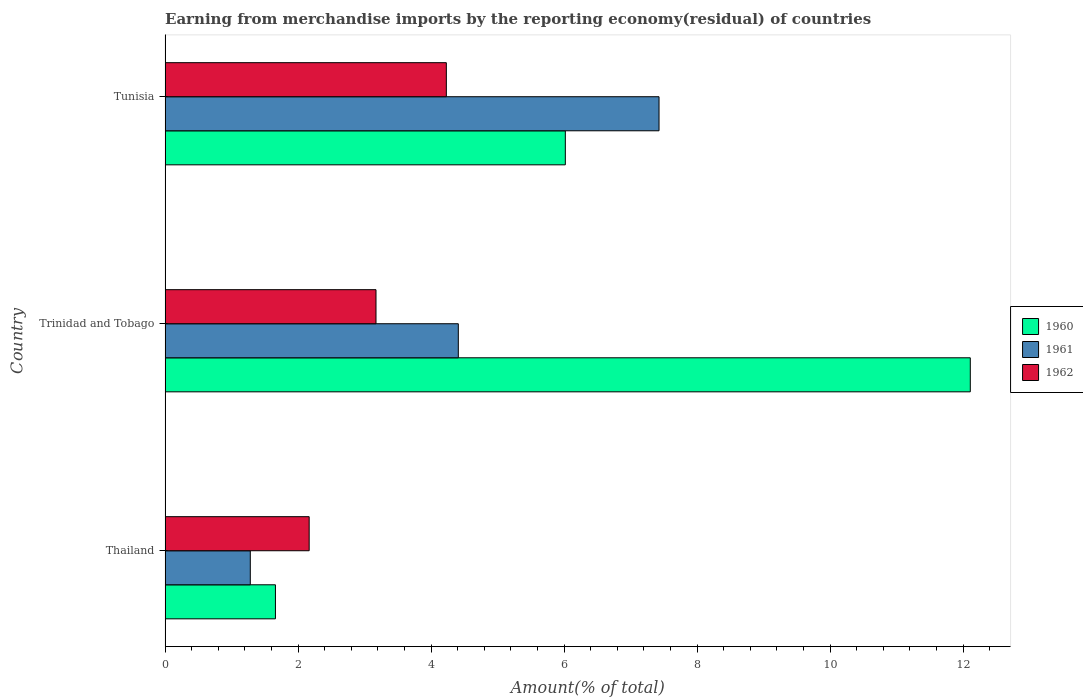How many different coloured bars are there?
Provide a short and direct response. 3. How many groups of bars are there?
Your answer should be compact. 3. Are the number of bars per tick equal to the number of legend labels?
Give a very brief answer. Yes. Are the number of bars on each tick of the Y-axis equal?
Your response must be concise. Yes. What is the label of the 3rd group of bars from the top?
Ensure brevity in your answer.  Thailand. What is the percentage of amount earned from merchandise imports in 1961 in Tunisia?
Your answer should be very brief. 7.43. Across all countries, what is the maximum percentage of amount earned from merchandise imports in 1961?
Your answer should be very brief. 7.43. Across all countries, what is the minimum percentage of amount earned from merchandise imports in 1960?
Make the answer very short. 1.66. In which country was the percentage of amount earned from merchandise imports in 1962 maximum?
Keep it short and to the point. Tunisia. In which country was the percentage of amount earned from merchandise imports in 1961 minimum?
Your answer should be compact. Thailand. What is the total percentage of amount earned from merchandise imports in 1961 in the graph?
Ensure brevity in your answer.  13.12. What is the difference between the percentage of amount earned from merchandise imports in 1962 in Thailand and that in Tunisia?
Your response must be concise. -2.06. What is the difference between the percentage of amount earned from merchandise imports in 1960 in Thailand and the percentage of amount earned from merchandise imports in 1962 in Trinidad and Tobago?
Your answer should be compact. -1.51. What is the average percentage of amount earned from merchandise imports in 1961 per country?
Your response must be concise. 4.37. What is the difference between the percentage of amount earned from merchandise imports in 1962 and percentage of amount earned from merchandise imports in 1960 in Tunisia?
Provide a short and direct response. -1.79. In how many countries, is the percentage of amount earned from merchandise imports in 1960 greater than 11.2 %?
Your answer should be compact. 1. What is the ratio of the percentage of amount earned from merchandise imports in 1961 in Trinidad and Tobago to that in Tunisia?
Offer a terse response. 0.59. What is the difference between the highest and the second highest percentage of amount earned from merchandise imports in 1962?
Offer a very short reply. 1.06. What is the difference between the highest and the lowest percentage of amount earned from merchandise imports in 1962?
Your answer should be compact. 2.06. Is the sum of the percentage of amount earned from merchandise imports in 1962 in Trinidad and Tobago and Tunisia greater than the maximum percentage of amount earned from merchandise imports in 1960 across all countries?
Offer a terse response. No. What does the 1st bar from the top in Thailand represents?
Make the answer very short. 1962. What does the 1st bar from the bottom in Thailand represents?
Ensure brevity in your answer.  1960. Are all the bars in the graph horizontal?
Provide a succinct answer. Yes. Does the graph contain any zero values?
Offer a very short reply. No. Does the graph contain grids?
Your answer should be compact. No. What is the title of the graph?
Your answer should be very brief. Earning from merchandise imports by the reporting economy(residual) of countries. What is the label or title of the X-axis?
Provide a succinct answer. Amount(% of total). What is the Amount(% of total) in 1960 in Thailand?
Keep it short and to the point. 1.66. What is the Amount(% of total) in 1961 in Thailand?
Provide a succinct answer. 1.28. What is the Amount(% of total) in 1962 in Thailand?
Offer a very short reply. 2.17. What is the Amount(% of total) of 1960 in Trinidad and Tobago?
Make the answer very short. 12.11. What is the Amount(% of total) in 1961 in Trinidad and Tobago?
Make the answer very short. 4.41. What is the Amount(% of total) in 1962 in Trinidad and Tobago?
Offer a very short reply. 3.17. What is the Amount(% of total) in 1960 in Tunisia?
Offer a terse response. 6.02. What is the Amount(% of total) of 1961 in Tunisia?
Provide a short and direct response. 7.43. What is the Amount(% of total) of 1962 in Tunisia?
Your answer should be very brief. 4.23. Across all countries, what is the maximum Amount(% of total) in 1960?
Offer a very short reply. 12.11. Across all countries, what is the maximum Amount(% of total) in 1961?
Your response must be concise. 7.43. Across all countries, what is the maximum Amount(% of total) in 1962?
Provide a short and direct response. 4.23. Across all countries, what is the minimum Amount(% of total) in 1960?
Provide a succinct answer. 1.66. Across all countries, what is the minimum Amount(% of total) of 1961?
Your answer should be compact. 1.28. Across all countries, what is the minimum Amount(% of total) in 1962?
Give a very brief answer. 2.17. What is the total Amount(% of total) in 1960 in the graph?
Make the answer very short. 19.78. What is the total Amount(% of total) in 1961 in the graph?
Offer a terse response. 13.12. What is the total Amount(% of total) of 1962 in the graph?
Your answer should be very brief. 9.57. What is the difference between the Amount(% of total) in 1960 in Thailand and that in Trinidad and Tobago?
Offer a terse response. -10.45. What is the difference between the Amount(% of total) of 1961 in Thailand and that in Trinidad and Tobago?
Offer a very short reply. -3.13. What is the difference between the Amount(% of total) of 1962 in Thailand and that in Trinidad and Tobago?
Keep it short and to the point. -1. What is the difference between the Amount(% of total) in 1960 in Thailand and that in Tunisia?
Your response must be concise. -4.36. What is the difference between the Amount(% of total) of 1961 in Thailand and that in Tunisia?
Offer a terse response. -6.15. What is the difference between the Amount(% of total) in 1962 in Thailand and that in Tunisia?
Give a very brief answer. -2.06. What is the difference between the Amount(% of total) in 1960 in Trinidad and Tobago and that in Tunisia?
Your answer should be very brief. 6.09. What is the difference between the Amount(% of total) of 1961 in Trinidad and Tobago and that in Tunisia?
Offer a terse response. -3.02. What is the difference between the Amount(% of total) of 1962 in Trinidad and Tobago and that in Tunisia?
Your answer should be very brief. -1.06. What is the difference between the Amount(% of total) of 1960 in Thailand and the Amount(% of total) of 1961 in Trinidad and Tobago?
Provide a succinct answer. -2.75. What is the difference between the Amount(% of total) of 1960 in Thailand and the Amount(% of total) of 1962 in Trinidad and Tobago?
Offer a terse response. -1.51. What is the difference between the Amount(% of total) of 1961 in Thailand and the Amount(% of total) of 1962 in Trinidad and Tobago?
Provide a succinct answer. -1.89. What is the difference between the Amount(% of total) of 1960 in Thailand and the Amount(% of total) of 1961 in Tunisia?
Make the answer very short. -5.77. What is the difference between the Amount(% of total) in 1960 in Thailand and the Amount(% of total) in 1962 in Tunisia?
Your answer should be compact. -2.57. What is the difference between the Amount(% of total) of 1961 in Thailand and the Amount(% of total) of 1962 in Tunisia?
Offer a terse response. -2.95. What is the difference between the Amount(% of total) of 1960 in Trinidad and Tobago and the Amount(% of total) of 1961 in Tunisia?
Ensure brevity in your answer.  4.68. What is the difference between the Amount(% of total) in 1960 in Trinidad and Tobago and the Amount(% of total) in 1962 in Tunisia?
Offer a very short reply. 7.88. What is the difference between the Amount(% of total) in 1961 in Trinidad and Tobago and the Amount(% of total) in 1962 in Tunisia?
Make the answer very short. 0.18. What is the average Amount(% of total) in 1960 per country?
Provide a short and direct response. 6.59. What is the average Amount(% of total) of 1961 per country?
Your answer should be compact. 4.37. What is the average Amount(% of total) in 1962 per country?
Your answer should be compact. 3.19. What is the difference between the Amount(% of total) of 1960 and Amount(% of total) of 1961 in Thailand?
Your response must be concise. 0.38. What is the difference between the Amount(% of total) in 1960 and Amount(% of total) in 1962 in Thailand?
Make the answer very short. -0.51. What is the difference between the Amount(% of total) in 1961 and Amount(% of total) in 1962 in Thailand?
Your answer should be compact. -0.89. What is the difference between the Amount(% of total) of 1960 and Amount(% of total) of 1961 in Trinidad and Tobago?
Your answer should be compact. 7.7. What is the difference between the Amount(% of total) in 1960 and Amount(% of total) in 1962 in Trinidad and Tobago?
Provide a succinct answer. 8.94. What is the difference between the Amount(% of total) in 1961 and Amount(% of total) in 1962 in Trinidad and Tobago?
Provide a succinct answer. 1.24. What is the difference between the Amount(% of total) in 1960 and Amount(% of total) in 1961 in Tunisia?
Ensure brevity in your answer.  -1.41. What is the difference between the Amount(% of total) of 1960 and Amount(% of total) of 1962 in Tunisia?
Make the answer very short. 1.79. What is the difference between the Amount(% of total) in 1961 and Amount(% of total) in 1962 in Tunisia?
Offer a very short reply. 3.2. What is the ratio of the Amount(% of total) in 1960 in Thailand to that in Trinidad and Tobago?
Offer a terse response. 0.14. What is the ratio of the Amount(% of total) in 1961 in Thailand to that in Trinidad and Tobago?
Your response must be concise. 0.29. What is the ratio of the Amount(% of total) of 1962 in Thailand to that in Trinidad and Tobago?
Provide a succinct answer. 0.68. What is the ratio of the Amount(% of total) of 1960 in Thailand to that in Tunisia?
Provide a succinct answer. 0.28. What is the ratio of the Amount(% of total) of 1961 in Thailand to that in Tunisia?
Give a very brief answer. 0.17. What is the ratio of the Amount(% of total) of 1962 in Thailand to that in Tunisia?
Provide a short and direct response. 0.51. What is the ratio of the Amount(% of total) in 1960 in Trinidad and Tobago to that in Tunisia?
Offer a very short reply. 2.01. What is the ratio of the Amount(% of total) of 1961 in Trinidad and Tobago to that in Tunisia?
Offer a very short reply. 0.59. What is the ratio of the Amount(% of total) of 1962 in Trinidad and Tobago to that in Tunisia?
Keep it short and to the point. 0.75. What is the difference between the highest and the second highest Amount(% of total) in 1960?
Make the answer very short. 6.09. What is the difference between the highest and the second highest Amount(% of total) in 1961?
Keep it short and to the point. 3.02. What is the difference between the highest and the second highest Amount(% of total) in 1962?
Offer a terse response. 1.06. What is the difference between the highest and the lowest Amount(% of total) in 1960?
Offer a very short reply. 10.45. What is the difference between the highest and the lowest Amount(% of total) in 1961?
Give a very brief answer. 6.15. What is the difference between the highest and the lowest Amount(% of total) in 1962?
Provide a succinct answer. 2.06. 